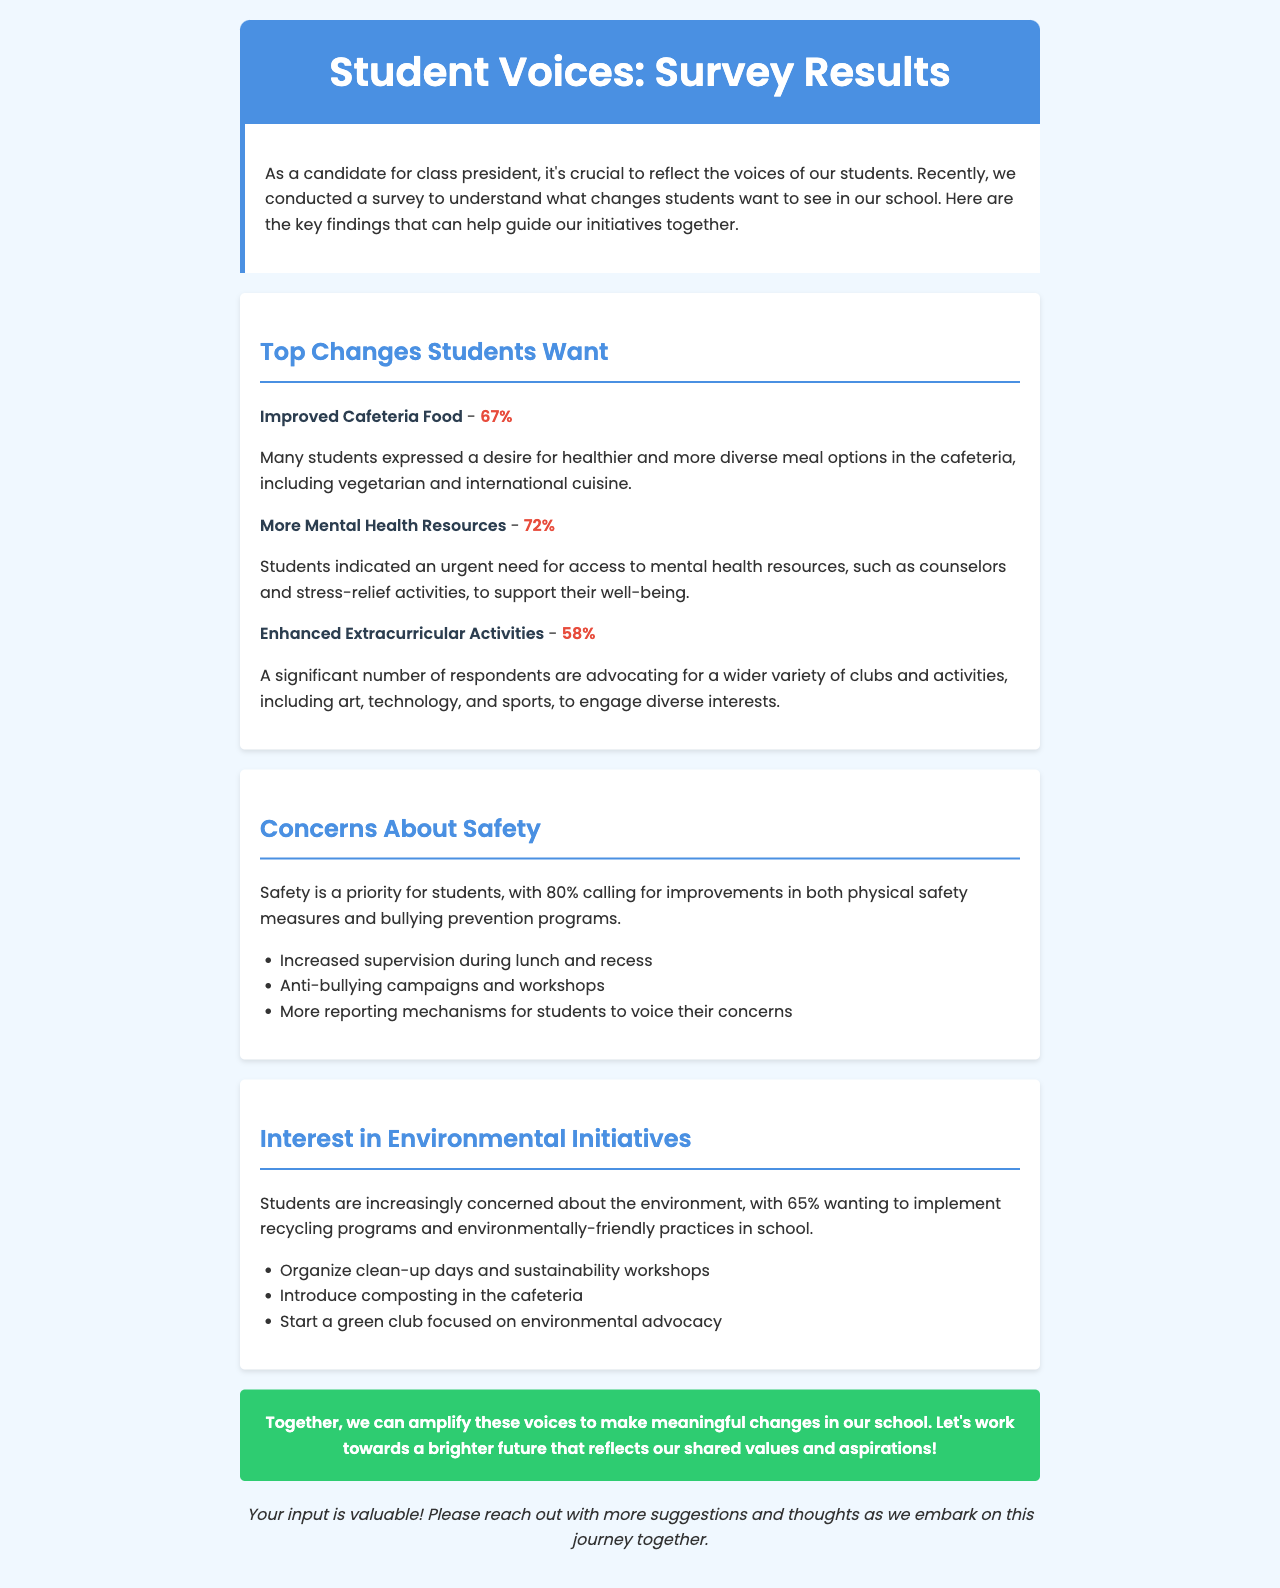What percentage of students want improved cafeteria food? The document states that 67% of students want improved cafeteria food.
Answer: 67% What is the top concern regarding safety? The top concern for safety is improvements in physical safety measures and bullying prevention programs, as indicated by 80% of students.
Answer: 80% How many students expressed a desire for more mental health resources? The document highlights that 72% of students indicated a need for more mental health resources.
Answer: 72% What kind of activities do students want more of? Students are advocating for enhanced extracurricular activities, specifically requesting a wider variety of clubs and activities.
Answer: extracurricular activities What initiatives related to the environment do students want? 65% of students want to implement recycling programs and environmentally-friendly practices in school.
Answer: recycling programs What is a suggested action for improving safety during lunch? The document suggests increased supervision during lunch as a measure for improving safety.
Answer: Increased supervision What does the document highlight as a need in the cafeteria? It emphasizes the desire for healthier and more diverse meal options in the cafeteria.
Answer: healthier and more diverse meal options What type of clubs do students want to see? Students want to see a green club focused on environmental advocacy among other clubs.
Answer: green club What is the call to action in the newsletter? The call to action is to work together to amplify student voices for meaningful changes.
Answer: amplify these voices 